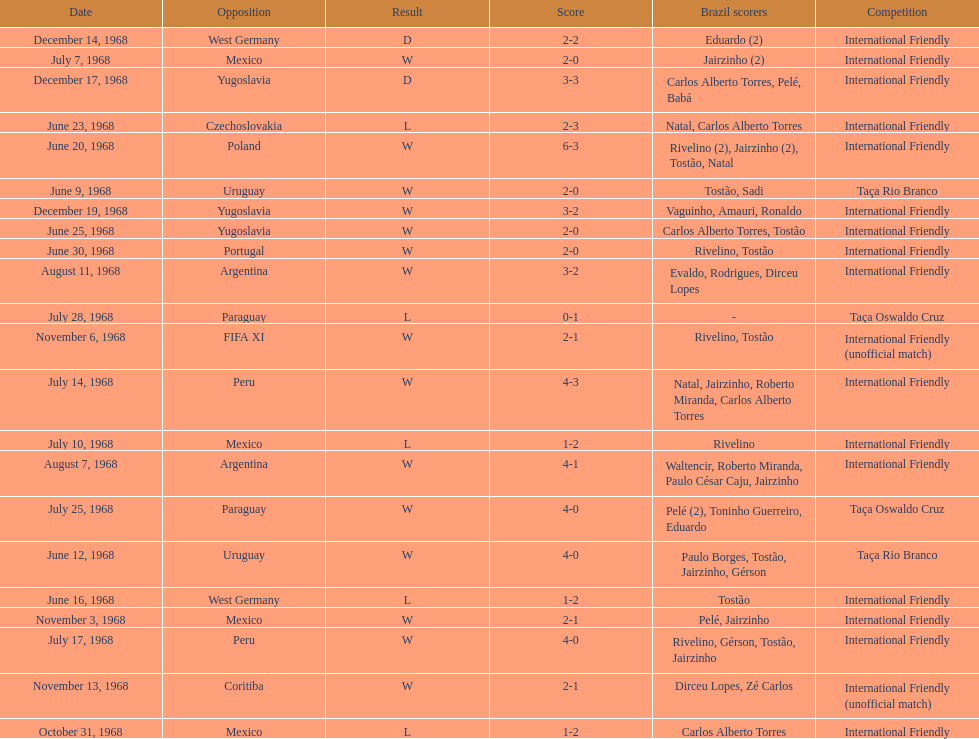What year has the highest scoring game? 1968. 